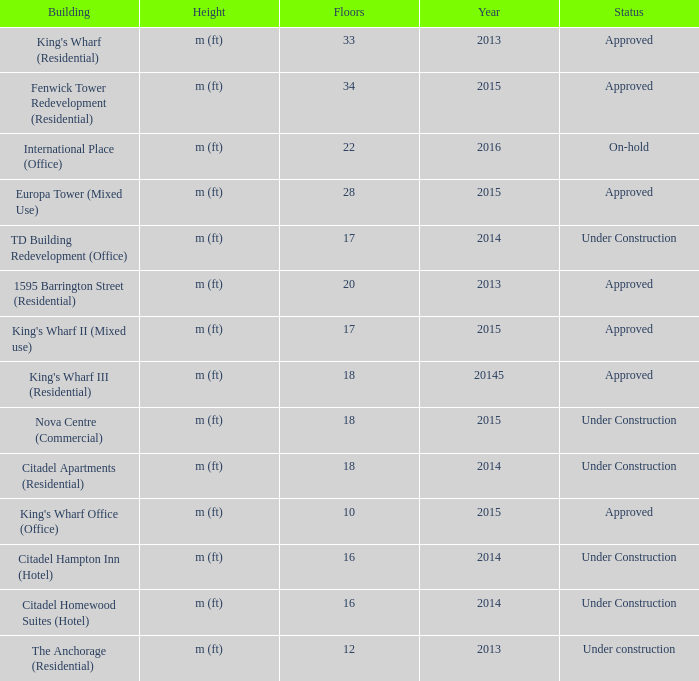What is the count of floors in the td building redevelopment (office)? 17.0. 